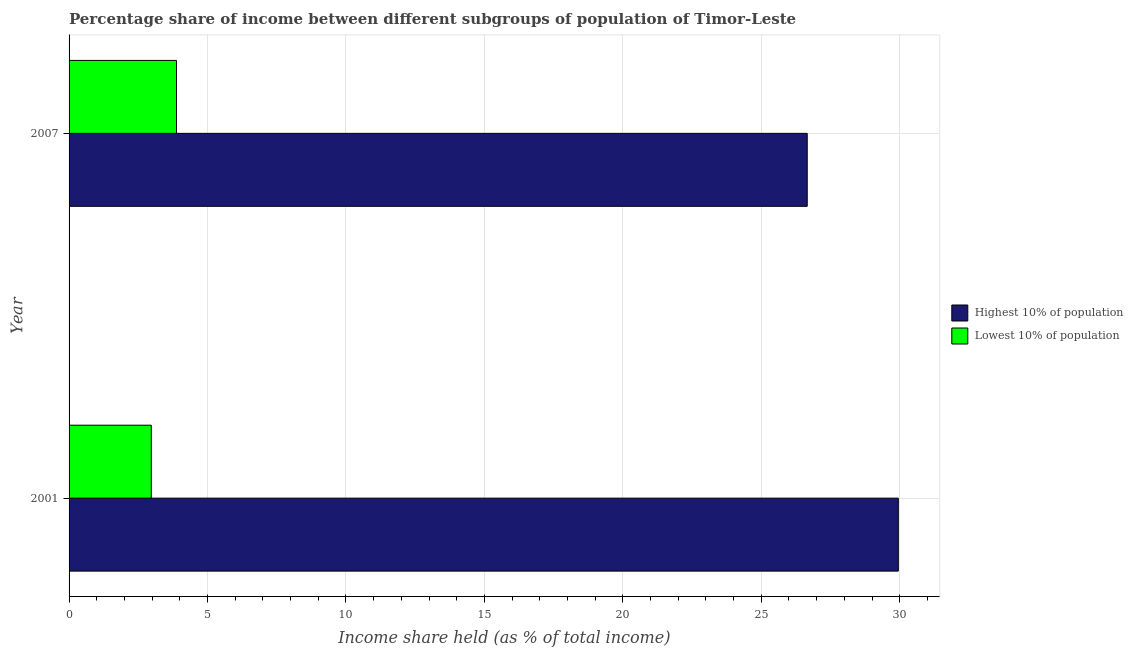How many bars are there on the 2nd tick from the top?
Offer a terse response. 2. How many bars are there on the 2nd tick from the bottom?
Your answer should be very brief. 2. What is the label of the 2nd group of bars from the top?
Give a very brief answer. 2001. What is the income share held by highest 10% of the population in 2007?
Keep it short and to the point. 26.66. Across all years, what is the maximum income share held by highest 10% of the population?
Keep it short and to the point. 29.95. Across all years, what is the minimum income share held by lowest 10% of the population?
Your answer should be compact. 2.97. What is the total income share held by lowest 10% of the population in the graph?
Offer a terse response. 6.85. What is the difference between the income share held by lowest 10% of the population in 2001 and that in 2007?
Your answer should be compact. -0.91. What is the difference between the income share held by lowest 10% of the population in 2007 and the income share held by highest 10% of the population in 2001?
Offer a terse response. -26.07. What is the average income share held by lowest 10% of the population per year?
Make the answer very short. 3.42. In the year 2001, what is the difference between the income share held by highest 10% of the population and income share held by lowest 10% of the population?
Your answer should be compact. 26.98. In how many years, is the income share held by lowest 10% of the population greater than 4 %?
Provide a succinct answer. 0. What is the ratio of the income share held by lowest 10% of the population in 2001 to that in 2007?
Your answer should be compact. 0.77. In how many years, is the income share held by highest 10% of the population greater than the average income share held by highest 10% of the population taken over all years?
Your response must be concise. 1. What does the 1st bar from the top in 2007 represents?
Offer a terse response. Lowest 10% of population. What does the 2nd bar from the bottom in 2007 represents?
Offer a very short reply. Lowest 10% of population. Are all the bars in the graph horizontal?
Offer a terse response. Yes. What is the difference between two consecutive major ticks on the X-axis?
Provide a succinct answer. 5. Does the graph contain any zero values?
Provide a short and direct response. No. How many legend labels are there?
Provide a short and direct response. 2. How are the legend labels stacked?
Your answer should be compact. Vertical. What is the title of the graph?
Ensure brevity in your answer.  Percentage share of income between different subgroups of population of Timor-Leste. What is the label or title of the X-axis?
Offer a terse response. Income share held (as % of total income). What is the label or title of the Y-axis?
Offer a very short reply. Year. What is the Income share held (as % of total income) of Highest 10% of population in 2001?
Provide a short and direct response. 29.95. What is the Income share held (as % of total income) in Lowest 10% of population in 2001?
Make the answer very short. 2.97. What is the Income share held (as % of total income) of Highest 10% of population in 2007?
Your answer should be compact. 26.66. What is the Income share held (as % of total income) in Lowest 10% of population in 2007?
Keep it short and to the point. 3.88. Across all years, what is the maximum Income share held (as % of total income) of Highest 10% of population?
Ensure brevity in your answer.  29.95. Across all years, what is the maximum Income share held (as % of total income) in Lowest 10% of population?
Your answer should be very brief. 3.88. Across all years, what is the minimum Income share held (as % of total income) of Highest 10% of population?
Ensure brevity in your answer.  26.66. Across all years, what is the minimum Income share held (as % of total income) of Lowest 10% of population?
Give a very brief answer. 2.97. What is the total Income share held (as % of total income) in Highest 10% of population in the graph?
Provide a short and direct response. 56.61. What is the total Income share held (as % of total income) in Lowest 10% of population in the graph?
Offer a terse response. 6.85. What is the difference between the Income share held (as % of total income) of Highest 10% of population in 2001 and that in 2007?
Offer a very short reply. 3.29. What is the difference between the Income share held (as % of total income) in Lowest 10% of population in 2001 and that in 2007?
Provide a short and direct response. -0.91. What is the difference between the Income share held (as % of total income) in Highest 10% of population in 2001 and the Income share held (as % of total income) in Lowest 10% of population in 2007?
Keep it short and to the point. 26.07. What is the average Income share held (as % of total income) in Highest 10% of population per year?
Offer a terse response. 28.3. What is the average Income share held (as % of total income) in Lowest 10% of population per year?
Give a very brief answer. 3.42. In the year 2001, what is the difference between the Income share held (as % of total income) of Highest 10% of population and Income share held (as % of total income) of Lowest 10% of population?
Provide a short and direct response. 26.98. In the year 2007, what is the difference between the Income share held (as % of total income) of Highest 10% of population and Income share held (as % of total income) of Lowest 10% of population?
Provide a short and direct response. 22.78. What is the ratio of the Income share held (as % of total income) of Highest 10% of population in 2001 to that in 2007?
Your answer should be compact. 1.12. What is the ratio of the Income share held (as % of total income) of Lowest 10% of population in 2001 to that in 2007?
Offer a very short reply. 0.77. What is the difference between the highest and the second highest Income share held (as % of total income) of Highest 10% of population?
Provide a short and direct response. 3.29. What is the difference between the highest and the second highest Income share held (as % of total income) of Lowest 10% of population?
Your response must be concise. 0.91. What is the difference between the highest and the lowest Income share held (as % of total income) in Highest 10% of population?
Provide a succinct answer. 3.29. What is the difference between the highest and the lowest Income share held (as % of total income) in Lowest 10% of population?
Your answer should be compact. 0.91. 